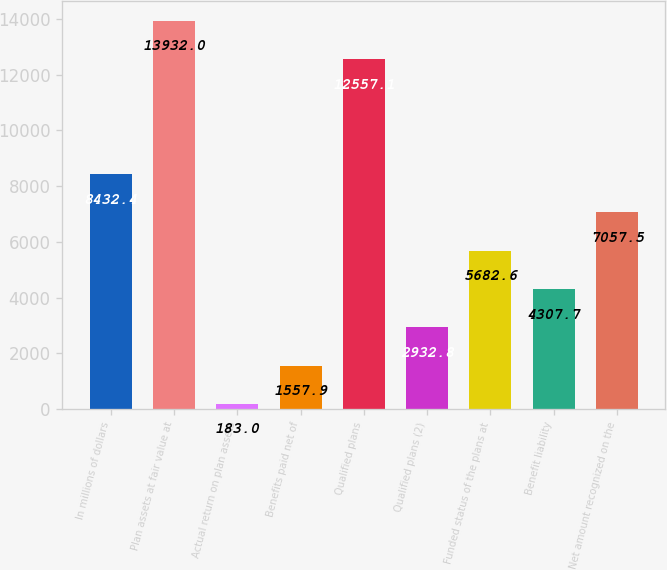Convert chart to OTSL. <chart><loc_0><loc_0><loc_500><loc_500><bar_chart><fcel>In millions of dollars<fcel>Plan assets at fair value at<fcel>Actual return on plan assets<fcel>Benefits paid net of<fcel>Qualified plans<fcel>Qualified plans (2)<fcel>Funded status of the plans at<fcel>Benefit liability<fcel>Net amount recognized on the<nl><fcel>8432.4<fcel>13932<fcel>183<fcel>1557.9<fcel>12557.1<fcel>2932.8<fcel>5682.6<fcel>4307.7<fcel>7057.5<nl></chart> 